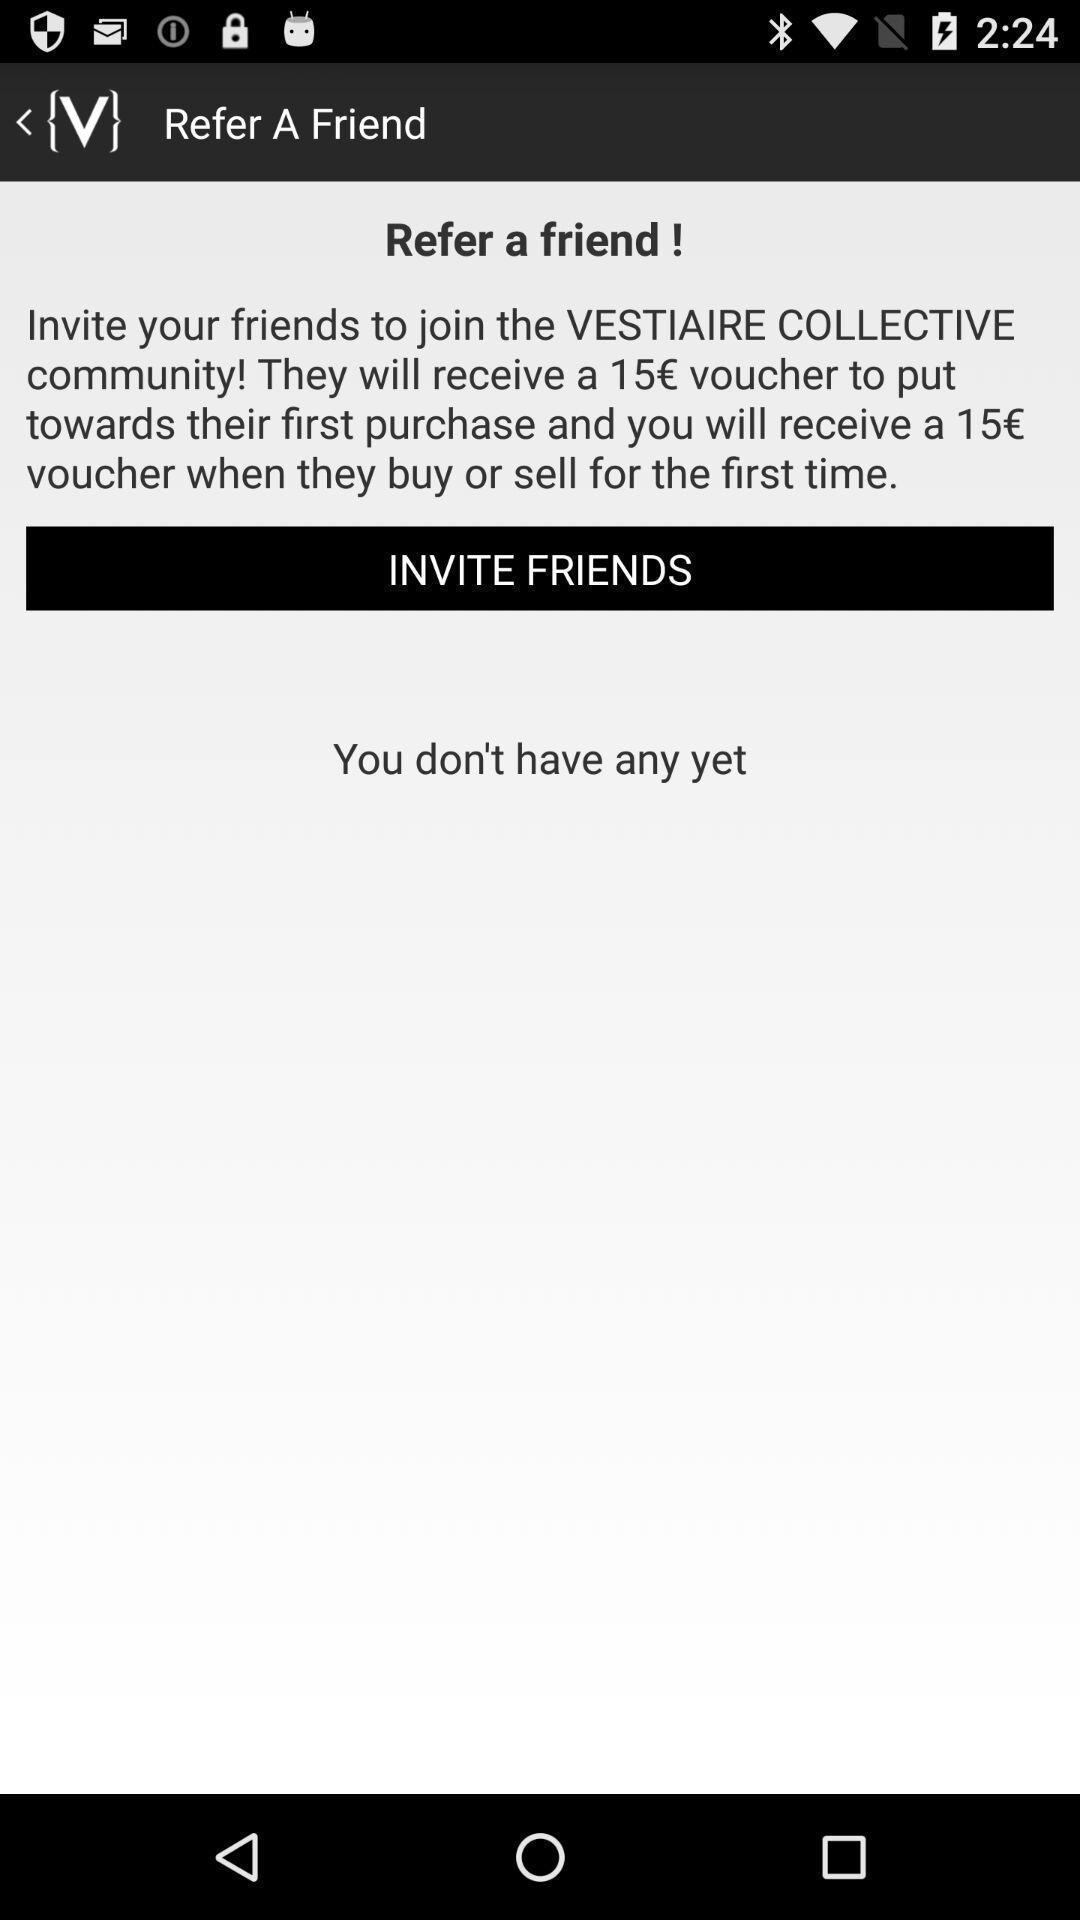Tell me about the visual elements in this screen capture. Screen shows refer a friend for shopping app. 